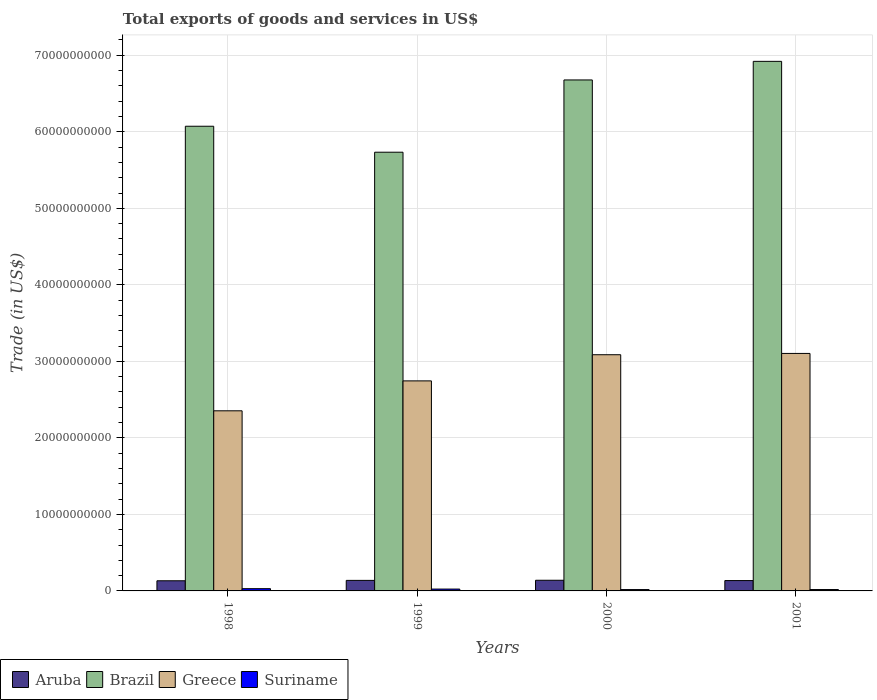How many different coloured bars are there?
Your response must be concise. 4. Are the number of bars per tick equal to the number of legend labels?
Your answer should be very brief. Yes. How many bars are there on the 4th tick from the left?
Your answer should be compact. 4. What is the label of the 1st group of bars from the left?
Your answer should be compact. 1998. In how many cases, is the number of bars for a given year not equal to the number of legend labels?
Offer a very short reply. 0. What is the total exports of goods and services in Greece in 1999?
Offer a very short reply. 2.74e+1. Across all years, what is the maximum total exports of goods and services in Aruba?
Your answer should be compact. 1.39e+09. Across all years, what is the minimum total exports of goods and services in Brazil?
Your answer should be very brief. 5.73e+1. In which year was the total exports of goods and services in Suriname minimum?
Your answer should be compact. 2000. What is the total total exports of goods and services in Greece in the graph?
Your answer should be very brief. 1.13e+11. What is the difference between the total exports of goods and services in Brazil in 1999 and that in 2001?
Ensure brevity in your answer.  -1.19e+1. What is the difference between the total exports of goods and services in Greece in 2000 and the total exports of goods and services in Brazil in 1998?
Give a very brief answer. -2.99e+1. What is the average total exports of goods and services in Brazil per year?
Your answer should be compact. 6.35e+1. In the year 1998, what is the difference between the total exports of goods and services in Suriname and total exports of goods and services in Greece?
Make the answer very short. -2.32e+1. In how many years, is the total exports of goods and services in Suriname greater than 36000000000 US$?
Ensure brevity in your answer.  0. What is the ratio of the total exports of goods and services in Greece in 1998 to that in 2000?
Offer a terse response. 0.76. Is the difference between the total exports of goods and services in Suriname in 1999 and 2001 greater than the difference between the total exports of goods and services in Greece in 1999 and 2001?
Make the answer very short. Yes. What is the difference between the highest and the second highest total exports of goods and services in Greece?
Make the answer very short. 1.71e+08. What is the difference between the highest and the lowest total exports of goods and services in Brazil?
Keep it short and to the point. 1.19e+1. Is the sum of the total exports of goods and services in Suriname in 1998 and 2001 greater than the maximum total exports of goods and services in Brazil across all years?
Provide a succinct answer. No. What does the 3rd bar from the right in 2001 represents?
Your answer should be compact. Brazil. How many years are there in the graph?
Ensure brevity in your answer.  4. Does the graph contain grids?
Your answer should be compact. Yes. What is the title of the graph?
Your answer should be very brief. Total exports of goods and services in US$. What is the label or title of the X-axis?
Provide a succinct answer. Years. What is the label or title of the Y-axis?
Keep it short and to the point. Trade (in US$). What is the Trade (in US$) in Aruba in 1998?
Offer a very short reply. 1.33e+09. What is the Trade (in US$) in Brazil in 1998?
Provide a short and direct response. 6.07e+1. What is the Trade (in US$) in Greece in 1998?
Your response must be concise. 2.35e+1. What is the Trade (in US$) in Suriname in 1998?
Offer a terse response. 2.94e+08. What is the Trade (in US$) of Aruba in 1999?
Make the answer very short. 1.38e+09. What is the Trade (in US$) of Brazil in 1999?
Your answer should be compact. 5.73e+1. What is the Trade (in US$) of Greece in 1999?
Keep it short and to the point. 2.74e+1. What is the Trade (in US$) in Suriname in 1999?
Ensure brevity in your answer.  2.41e+08. What is the Trade (in US$) of Aruba in 2000?
Offer a very short reply. 1.39e+09. What is the Trade (in US$) of Brazil in 2000?
Provide a succinct answer. 6.68e+1. What is the Trade (in US$) in Greece in 2000?
Ensure brevity in your answer.  3.09e+1. What is the Trade (in US$) of Suriname in 2000?
Make the answer very short. 1.76e+08. What is the Trade (in US$) of Aruba in 2001?
Your response must be concise. 1.35e+09. What is the Trade (in US$) of Brazil in 2001?
Your answer should be compact. 6.92e+1. What is the Trade (in US$) in Greece in 2001?
Your answer should be very brief. 3.10e+1. What is the Trade (in US$) in Suriname in 2001?
Offer a very short reply. 1.80e+08. Across all years, what is the maximum Trade (in US$) in Aruba?
Your answer should be very brief. 1.39e+09. Across all years, what is the maximum Trade (in US$) of Brazil?
Provide a short and direct response. 6.92e+1. Across all years, what is the maximum Trade (in US$) of Greece?
Offer a terse response. 3.10e+1. Across all years, what is the maximum Trade (in US$) in Suriname?
Ensure brevity in your answer.  2.94e+08. Across all years, what is the minimum Trade (in US$) in Aruba?
Keep it short and to the point. 1.33e+09. Across all years, what is the minimum Trade (in US$) in Brazil?
Your answer should be compact. 5.73e+1. Across all years, what is the minimum Trade (in US$) in Greece?
Offer a terse response. 2.35e+1. Across all years, what is the minimum Trade (in US$) of Suriname?
Offer a terse response. 1.76e+08. What is the total Trade (in US$) in Aruba in the graph?
Offer a very short reply. 5.45e+09. What is the total Trade (in US$) of Brazil in the graph?
Provide a succinct answer. 2.54e+11. What is the total Trade (in US$) of Greece in the graph?
Offer a terse response. 1.13e+11. What is the total Trade (in US$) of Suriname in the graph?
Provide a succinct answer. 8.91e+08. What is the difference between the Trade (in US$) of Aruba in 1998 and that in 1999?
Provide a succinct answer. -5.11e+07. What is the difference between the Trade (in US$) in Brazil in 1998 and that in 1999?
Provide a short and direct response. 3.39e+09. What is the difference between the Trade (in US$) of Greece in 1998 and that in 1999?
Make the answer very short. -3.91e+09. What is the difference between the Trade (in US$) of Suriname in 1998 and that in 1999?
Offer a terse response. 5.29e+07. What is the difference between the Trade (in US$) of Aruba in 1998 and that in 2000?
Give a very brief answer. -6.73e+07. What is the difference between the Trade (in US$) in Brazil in 1998 and that in 2000?
Offer a very short reply. -6.05e+09. What is the difference between the Trade (in US$) of Greece in 1998 and that in 2000?
Keep it short and to the point. -7.33e+09. What is the difference between the Trade (in US$) of Suriname in 1998 and that in 2000?
Make the answer very short. 1.18e+08. What is the difference between the Trade (in US$) in Aruba in 1998 and that in 2001?
Offer a terse response. -2.73e+07. What is the difference between the Trade (in US$) in Brazil in 1998 and that in 2001?
Your answer should be very brief. -8.48e+09. What is the difference between the Trade (in US$) of Greece in 1998 and that in 2001?
Provide a succinct answer. -7.50e+09. What is the difference between the Trade (in US$) of Suriname in 1998 and that in 2001?
Make the answer very short. 1.14e+08. What is the difference between the Trade (in US$) in Aruba in 1999 and that in 2000?
Provide a short and direct response. -1.62e+07. What is the difference between the Trade (in US$) of Brazil in 1999 and that in 2000?
Ensure brevity in your answer.  -9.44e+09. What is the difference between the Trade (in US$) of Greece in 1999 and that in 2000?
Keep it short and to the point. -3.42e+09. What is the difference between the Trade (in US$) in Suriname in 1999 and that in 2000?
Make the answer very short. 6.51e+07. What is the difference between the Trade (in US$) in Aruba in 1999 and that in 2001?
Ensure brevity in your answer.  2.38e+07. What is the difference between the Trade (in US$) in Brazil in 1999 and that in 2001?
Keep it short and to the point. -1.19e+1. What is the difference between the Trade (in US$) of Greece in 1999 and that in 2001?
Give a very brief answer. -3.59e+09. What is the difference between the Trade (in US$) of Suriname in 1999 and that in 2001?
Ensure brevity in your answer.  6.12e+07. What is the difference between the Trade (in US$) of Aruba in 2000 and that in 2001?
Your answer should be compact. 4.00e+07. What is the difference between the Trade (in US$) in Brazil in 2000 and that in 2001?
Your answer should be compact. -2.43e+09. What is the difference between the Trade (in US$) in Greece in 2000 and that in 2001?
Give a very brief answer. -1.71e+08. What is the difference between the Trade (in US$) of Suriname in 2000 and that in 2001?
Ensure brevity in your answer.  -3.95e+06. What is the difference between the Trade (in US$) of Aruba in 1998 and the Trade (in US$) of Brazil in 1999?
Your answer should be very brief. -5.60e+1. What is the difference between the Trade (in US$) of Aruba in 1998 and the Trade (in US$) of Greece in 1999?
Provide a short and direct response. -2.61e+1. What is the difference between the Trade (in US$) in Aruba in 1998 and the Trade (in US$) in Suriname in 1999?
Provide a succinct answer. 1.09e+09. What is the difference between the Trade (in US$) in Brazil in 1998 and the Trade (in US$) in Greece in 1999?
Offer a very short reply. 3.33e+1. What is the difference between the Trade (in US$) in Brazil in 1998 and the Trade (in US$) in Suriname in 1999?
Give a very brief answer. 6.05e+1. What is the difference between the Trade (in US$) in Greece in 1998 and the Trade (in US$) in Suriname in 1999?
Provide a short and direct response. 2.33e+1. What is the difference between the Trade (in US$) in Aruba in 1998 and the Trade (in US$) in Brazil in 2000?
Keep it short and to the point. -6.54e+1. What is the difference between the Trade (in US$) in Aruba in 1998 and the Trade (in US$) in Greece in 2000?
Make the answer very short. -2.95e+1. What is the difference between the Trade (in US$) in Aruba in 1998 and the Trade (in US$) in Suriname in 2000?
Make the answer very short. 1.15e+09. What is the difference between the Trade (in US$) of Brazil in 1998 and the Trade (in US$) of Greece in 2000?
Your answer should be compact. 2.99e+1. What is the difference between the Trade (in US$) in Brazil in 1998 and the Trade (in US$) in Suriname in 2000?
Offer a very short reply. 6.05e+1. What is the difference between the Trade (in US$) in Greece in 1998 and the Trade (in US$) in Suriname in 2000?
Give a very brief answer. 2.34e+1. What is the difference between the Trade (in US$) in Aruba in 1998 and the Trade (in US$) in Brazil in 2001?
Offer a terse response. -6.79e+1. What is the difference between the Trade (in US$) of Aruba in 1998 and the Trade (in US$) of Greece in 2001?
Your response must be concise. -2.97e+1. What is the difference between the Trade (in US$) in Aruba in 1998 and the Trade (in US$) in Suriname in 2001?
Provide a succinct answer. 1.15e+09. What is the difference between the Trade (in US$) in Brazil in 1998 and the Trade (in US$) in Greece in 2001?
Make the answer very short. 2.97e+1. What is the difference between the Trade (in US$) in Brazil in 1998 and the Trade (in US$) in Suriname in 2001?
Provide a short and direct response. 6.05e+1. What is the difference between the Trade (in US$) of Greece in 1998 and the Trade (in US$) of Suriname in 2001?
Provide a short and direct response. 2.34e+1. What is the difference between the Trade (in US$) of Aruba in 1999 and the Trade (in US$) of Brazil in 2000?
Offer a very short reply. -6.54e+1. What is the difference between the Trade (in US$) of Aruba in 1999 and the Trade (in US$) of Greece in 2000?
Make the answer very short. -2.95e+1. What is the difference between the Trade (in US$) in Aruba in 1999 and the Trade (in US$) in Suriname in 2000?
Your answer should be compact. 1.20e+09. What is the difference between the Trade (in US$) of Brazil in 1999 and the Trade (in US$) of Greece in 2000?
Give a very brief answer. 2.65e+1. What is the difference between the Trade (in US$) in Brazil in 1999 and the Trade (in US$) in Suriname in 2000?
Keep it short and to the point. 5.72e+1. What is the difference between the Trade (in US$) in Greece in 1999 and the Trade (in US$) in Suriname in 2000?
Provide a succinct answer. 2.73e+1. What is the difference between the Trade (in US$) of Aruba in 1999 and the Trade (in US$) of Brazil in 2001?
Keep it short and to the point. -6.78e+1. What is the difference between the Trade (in US$) in Aruba in 1999 and the Trade (in US$) in Greece in 2001?
Your answer should be compact. -2.97e+1. What is the difference between the Trade (in US$) of Aruba in 1999 and the Trade (in US$) of Suriname in 2001?
Keep it short and to the point. 1.20e+09. What is the difference between the Trade (in US$) in Brazil in 1999 and the Trade (in US$) in Greece in 2001?
Offer a very short reply. 2.63e+1. What is the difference between the Trade (in US$) in Brazil in 1999 and the Trade (in US$) in Suriname in 2001?
Your response must be concise. 5.72e+1. What is the difference between the Trade (in US$) of Greece in 1999 and the Trade (in US$) of Suriname in 2001?
Keep it short and to the point. 2.73e+1. What is the difference between the Trade (in US$) in Aruba in 2000 and the Trade (in US$) in Brazil in 2001?
Keep it short and to the point. -6.78e+1. What is the difference between the Trade (in US$) of Aruba in 2000 and the Trade (in US$) of Greece in 2001?
Give a very brief answer. -2.96e+1. What is the difference between the Trade (in US$) of Aruba in 2000 and the Trade (in US$) of Suriname in 2001?
Provide a succinct answer. 1.21e+09. What is the difference between the Trade (in US$) in Brazil in 2000 and the Trade (in US$) in Greece in 2001?
Offer a terse response. 3.57e+1. What is the difference between the Trade (in US$) of Brazil in 2000 and the Trade (in US$) of Suriname in 2001?
Your answer should be compact. 6.66e+1. What is the difference between the Trade (in US$) of Greece in 2000 and the Trade (in US$) of Suriname in 2001?
Make the answer very short. 3.07e+1. What is the average Trade (in US$) in Aruba per year?
Ensure brevity in your answer.  1.36e+09. What is the average Trade (in US$) of Brazil per year?
Your response must be concise. 6.35e+1. What is the average Trade (in US$) of Greece per year?
Ensure brevity in your answer.  2.82e+1. What is the average Trade (in US$) in Suriname per year?
Keep it short and to the point. 2.23e+08. In the year 1998, what is the difference between the Trade (in US$) in Aruba and Trade (in US$) in Brazil?
Offer a very short reply. -5.94e+1. In the year 1998, what is the difference between the Trade (in US$) of Aruba and Trade (in US$) of Greece?
Give a very brief answer. -2.22e+1. In the year 1998, what is the difference between the Trade (in US$) in Aruba and Trade (in US$) in Suriname?
Offer a very short reply. 1.03e+09. In the year 1998, what is the difference between the Trade (in US$) of Brazil and Trade (in US$) of Greece?
Your answer should be very brief. 3.72e+1. In the year 1998, what is the difference between the Trade (in US$) in Brazil and Trade (in US$) in Suriname?
Make the answer very short. 6.04e+1. In the year 1998, what is the difference between the Trade (in US$) of Greece and Trade (in US$) of Suriname?
Your response must be concise. 2.32e+1. In the year 1999, what is the difference between the Trade (in US$) of Aruba and Trade (in US$) of Brazil?
Your answer should be compact. -5.60e+1. In the year 1999, what is the difference between the Trade (in US$) of Aruba and Trade (in US$) of Greece?
Keep it short and to the point. -2.61e+1. In the year 1999, what is the difference between the Trade (in US$) in Aruba and Trade (in US$) in Suriname?
Make the answer very short. 1.14e+09. In the year 1999, what is the difference between the Trade (in US$) of Brazil and Trade (in US$) of Greece?
Ensure brevity in your answer.  2.99e+1. In the year 1999, what is the difference between the Trade (in US$) of Brazil and Trade (in US$) of Suriname?
Make the answer very short. 5.71e+1. In the year 1999, what is the difference between the Trade (in US$) in Greece and Trade (in US$) in Suriname?
Ensure brevity in your answer.  2.72e+1. In the year 2000, what is the difference between the Trade (in US$) in Aruba and Trade (in US$) in Brazil?
Your answer should be very brief. -6.54e+1. In the year 2000, what is the difference between the Trade (in US$) of Aruba and Trade (in US$) of Greece?
Provide a short and direct response. -2.95e+1. In the year 2000, what is the difference between the Trade (in US$) of Aruba and Trade (in US$) of Suriname?
Provide a short and direct response. 1.22e+09. In the year 2000, what is the difference between the Trade (in US$) in Brazil and Trade (in US$) in Greece?
Offer a terse response. 3.59e+1. In the year 2000, what is the difference between the Trade (in US$) in Brazil and Trade (in US$) in Suriname?
Give a very brief answer. 6.66e+1. In the year 2000, what is the difference between the Trade (in US$) of Greece and Trade (in US$) of Suriname?
Your answer should be very brief. 3.07e+1. In the year 2001, what is the difference between the Trade (in US$) of Aruba and Trade (in US$) of Brazil?
Provide a succinct answer. -6.79e+1. In the year 2001, what is the difference between the Trade (in US$) of Aruba and Trade (in US$) of Greece?
Make the answer very short. -2.97e+1. In the year 2001, what is the difference between the Trade (in US$) in Aruba and Trade (in US$) in Suriname?
Provide a succinct answer. 1.17e+09. In the year 2001, what is the difference between the Trade (in US$) in Brazil and Trade (in US$) in Greece?
Your answer should be compact. 3.82e+1. In the year 2001, what is the difference between the Trade (in US$) in Brazil and Trade (in US$) in Suriname?
Give a very brief answer. 6.90e+1. In the year 2001, what is the difference between the Trade (in US$) in Greece and Trade (in US$) in Suriname?
Ensure brevity in your answer.  3.09e+1. What is the ratio of the Trade (in US$) of Aruba in 1998 to that in 1999?
Make the answer very short. 0.96. What is the ratio of the Trade (in US$) of Brazil in 1998 to that in 1999?
Your response must be concise. 1.06. What is the ratio of the Trade (in US$) of Greece in 1998 to that in 1999?
Provide a short and direct response. 0.86. What is the ratio of the Trade (in US$) of Suriname in 1998 to that in 1999?
Provide a short and direct response. 1.22. What is the ratio of the Trade (in US$) of Aruba in 1998 to that in 2000?
Give a very brief answer. 0.95. What is the ratio of the Trade (in US$) in Brazil in 1998 to that in 2000?
Offer a very short reply. 0.91. What is the ratio of the Trade (in US$) of Greece in 1998 to that in 2000?
Offer a terse response. 0.76. What is the ratio of the Trade (in US$) of Suriname in 1998 to that in 2000?
Offer a terse response. 1.67. What is the ratio of the Trade (in US$) of Aruba in 1998 to that in 2001?
Your answer should be compact. 0.98. What is the ratio of the Trade (in US$) in Brazil in 1998 to that in 2001?
Keep it short and to the point. 0.88. What is the ratio of the Trade (in US$) of Greece in 1998 to that in 2001?
Offer a terse response. 0.76. What is the ratio of the Trade (in US$) in Suriname in 1998 to that in 2001?
Your answer should be very brief. 1.63. What is the ratio of the Trade (in US$) in Aruba in 1999 to that in 2000?
Your answer should be very brief. 0.99. What is the ratio of the Trade (in US$) of Brazil in 1999 to that in 2000?
Provide a succinct answer. 0.86. What is the ratio of the Trade (in US$) of Greece in 1999 to that in 2000?
Provide a short and direct response. 0.89. What is the ratio of the Trade (in US$) in Suriname in 1999 to that in 2000?
Your response must be concise. 1.37. What is the ratio of the Trade (in US$) in Aruba in 1999 to that in 2001?
Provide a succinct answer. 1.02. What is the ratio of the Trade (in US$) of Brazil in 1999 to that in 2001?
Your answer should be compact. 0.83. What is the ratio of the Trade (in US$) of Greece in 1999 to that in 2001?
Provide a succinct answer. 0.88. What is the ratio of the Trade (in US$) in Suriname in 1999 to that in 2001?
Offer a terse response. 1.34. What is the ratio of the Trade (in US$) of Aruba in 2000 to that in 2001?
Your answer should be compact. 1.03. What is the ratio of the Trade (in US$) of Brazil in 2000 to that in 2001?
Your response must be concise. 0.96. What is the ratio of the Trade (in US$) in Suriname in 2000 to that in 2001?
Give a very brief answer. 0.98. What is the difference between the highest and the second highest Trade (in US$) in Aruba?
Your answer should be compact. 1.62e+07. What is the difference between the highest and the second highest Trade (in US$) in Brazil?
Your response must be concise. 2.43e+09. What is the difference between the highest and the second highest Trade (in US$) in Greece?
Keep it short and to the point. 1.71e+08. What is the difference between the highest and the second highest Trade (in US$) of Suriname?
Give a very brief answer. 5.29e+07. What is the difference between the highest and the lowest Trade (in US$) of Aruba?
Give a very brief answer. 6.73e+07. What is the difference between the highest and the lowest Trade (in US$) in Brazil?
Ensure brevity in your answer.  1.19e+1. What is the difference between the highest and the lowest Trade (in US$) in Greece?
Your response must be concise. 7.50e+09. What is the difference between the highest and the lowest Trade (in US$) of Suriname?
Your response must be concise. 1.18e+08. 